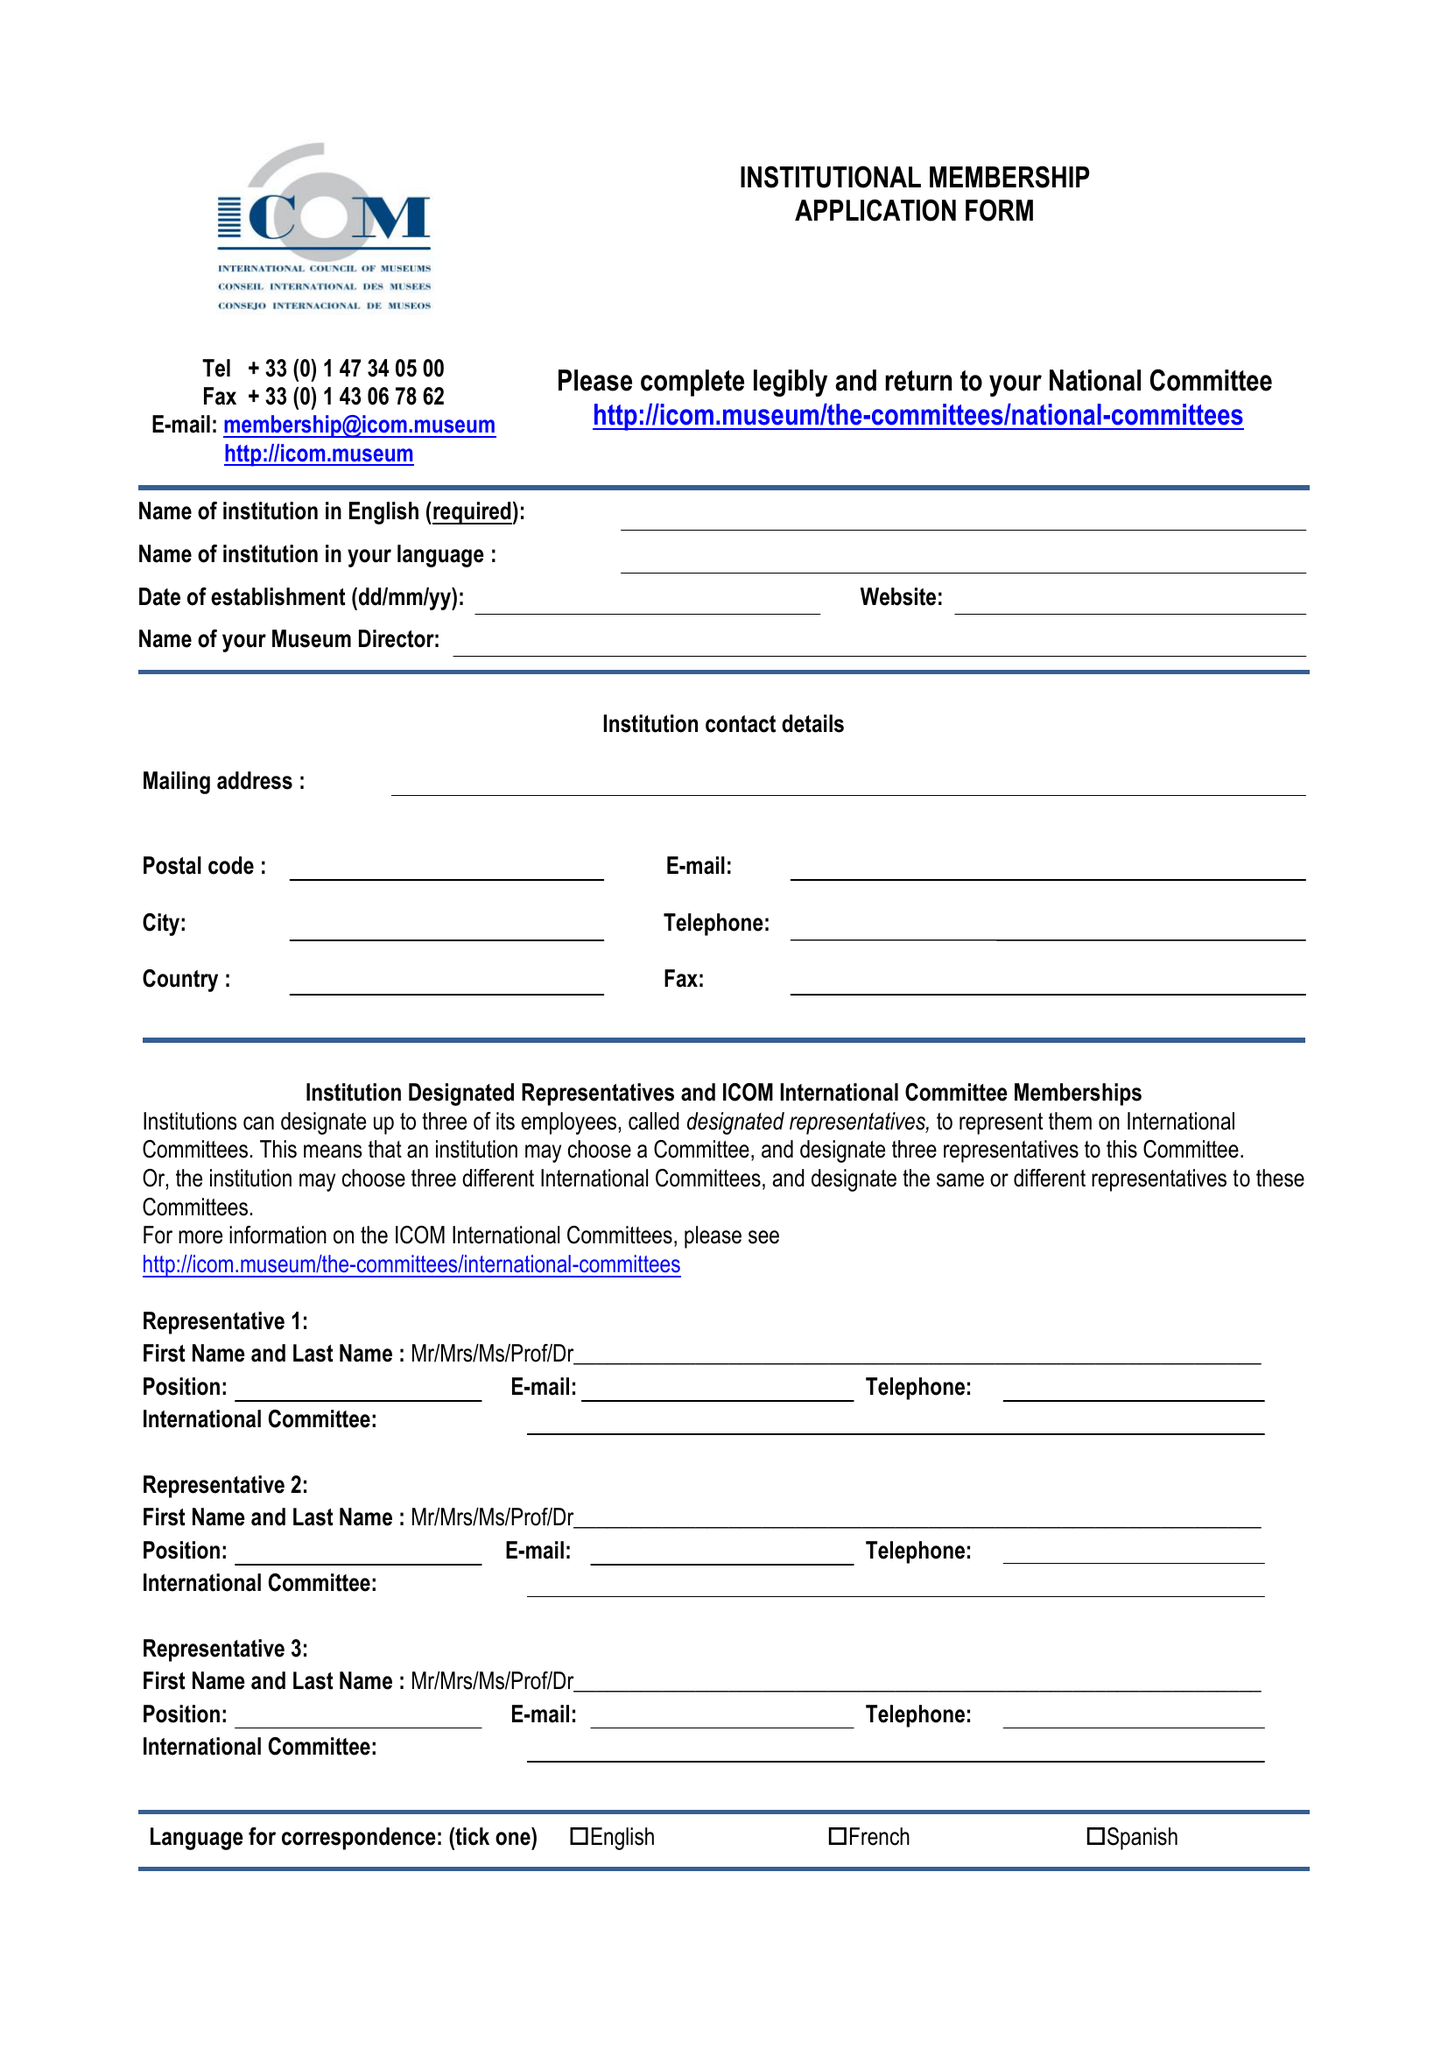What is the value for the charity_number?
Answer the question using a single word or phrase. 326410 